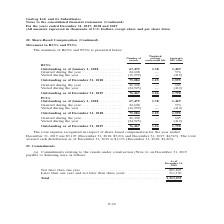From Gaslog's financial document, What are the two components of the share based compensation? The document shows two values: RCUs and PCUs. From the document: "Movement in RCUs and PCUs Movement in RCUs and PCUs..." Also, What was the number of awards of RCUs granted during the year in 2018? According to the financial document, 24,608 (in thousands). The relevant text states: "018 . 67,475 1.38 1,429 Granted during the year . 24,608 — 576 Vested during the year . (16,999) — (410)..." Also, What was the number of awards of PCUs granted during the year in 2018? According to the financial document, 24,608 (in thousands). The relevant text states: "018 . 67,475 1.38 1,429 Granted during the year . 24,608 — 576 Vested during the year . (16,999) — (410)..." Additionally, In which year was the total expense recognized in respect of share-based compensation the highest? According to the financial document, 2018. The relevant text states: "Continued) For the years ended December 31, 2017, 2018 and 2019 (All amounts expressed in thousands of U.S. Dollars, except share and per share data) Continued) For the years ended December 31, 2017, ..." Also, can you calculate: What was the change in total expense recognized from 2017 to 2018? Based on the calculation: $5,216 - $4,565 , the result is 651 (in thousands). This is based on the information: "December 31, 2018: $5,216 and December 31, 2017: $4,565). The total accrued cash distribution as of December 31, 2019 is $1,176 (December 31, 2018: $1,265) December 31, 2019 was $5,107 (December 31, 2..." The key data points involved are: 4,565, 5,216. Also, can you calculate: What was the percentage change in total accrued cash distribution from 2018 to 2019? To answer this question, I need to perform calculations using the financial data. The calculation is: ($1,176- $1,265)/$1,265 , which equals -7.04 (percentage). This is based on the information: "December 31, 2019 is $1,176 (December 31, 2018: $1,265). ued cash distribution as of December 31, 2019 is $1,176 (December 31, 2018: $1,265)...." The key data points involved are: 1,176, 1,265. 